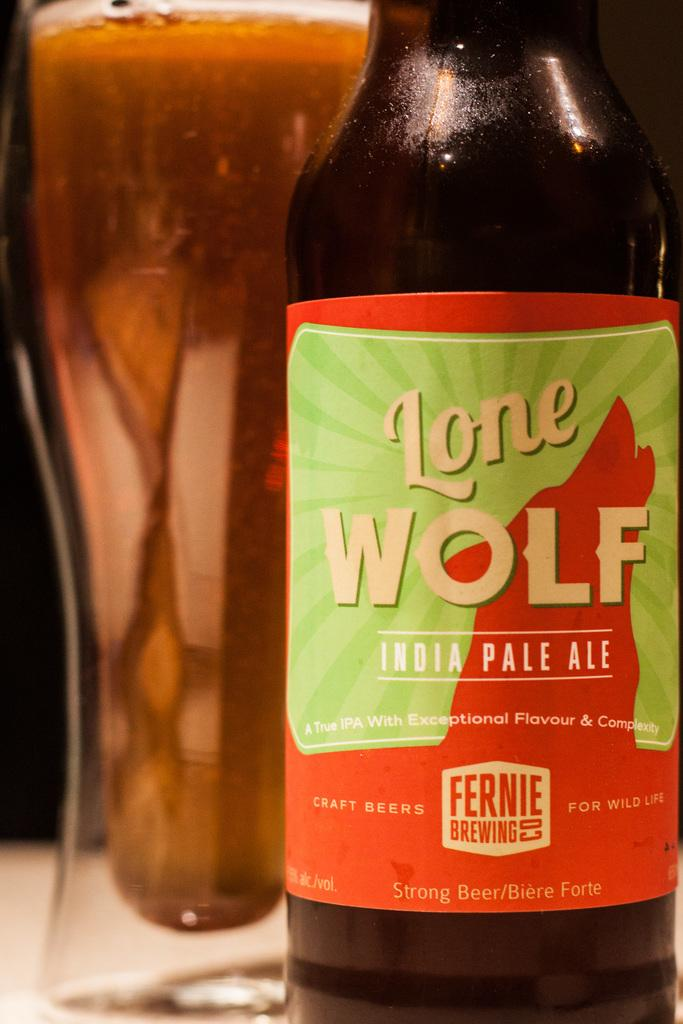<image>
Render a clear and concise summary of the photo. A bottle of beer that says Lone Wolf India Pale Ale is next to a full glass. 